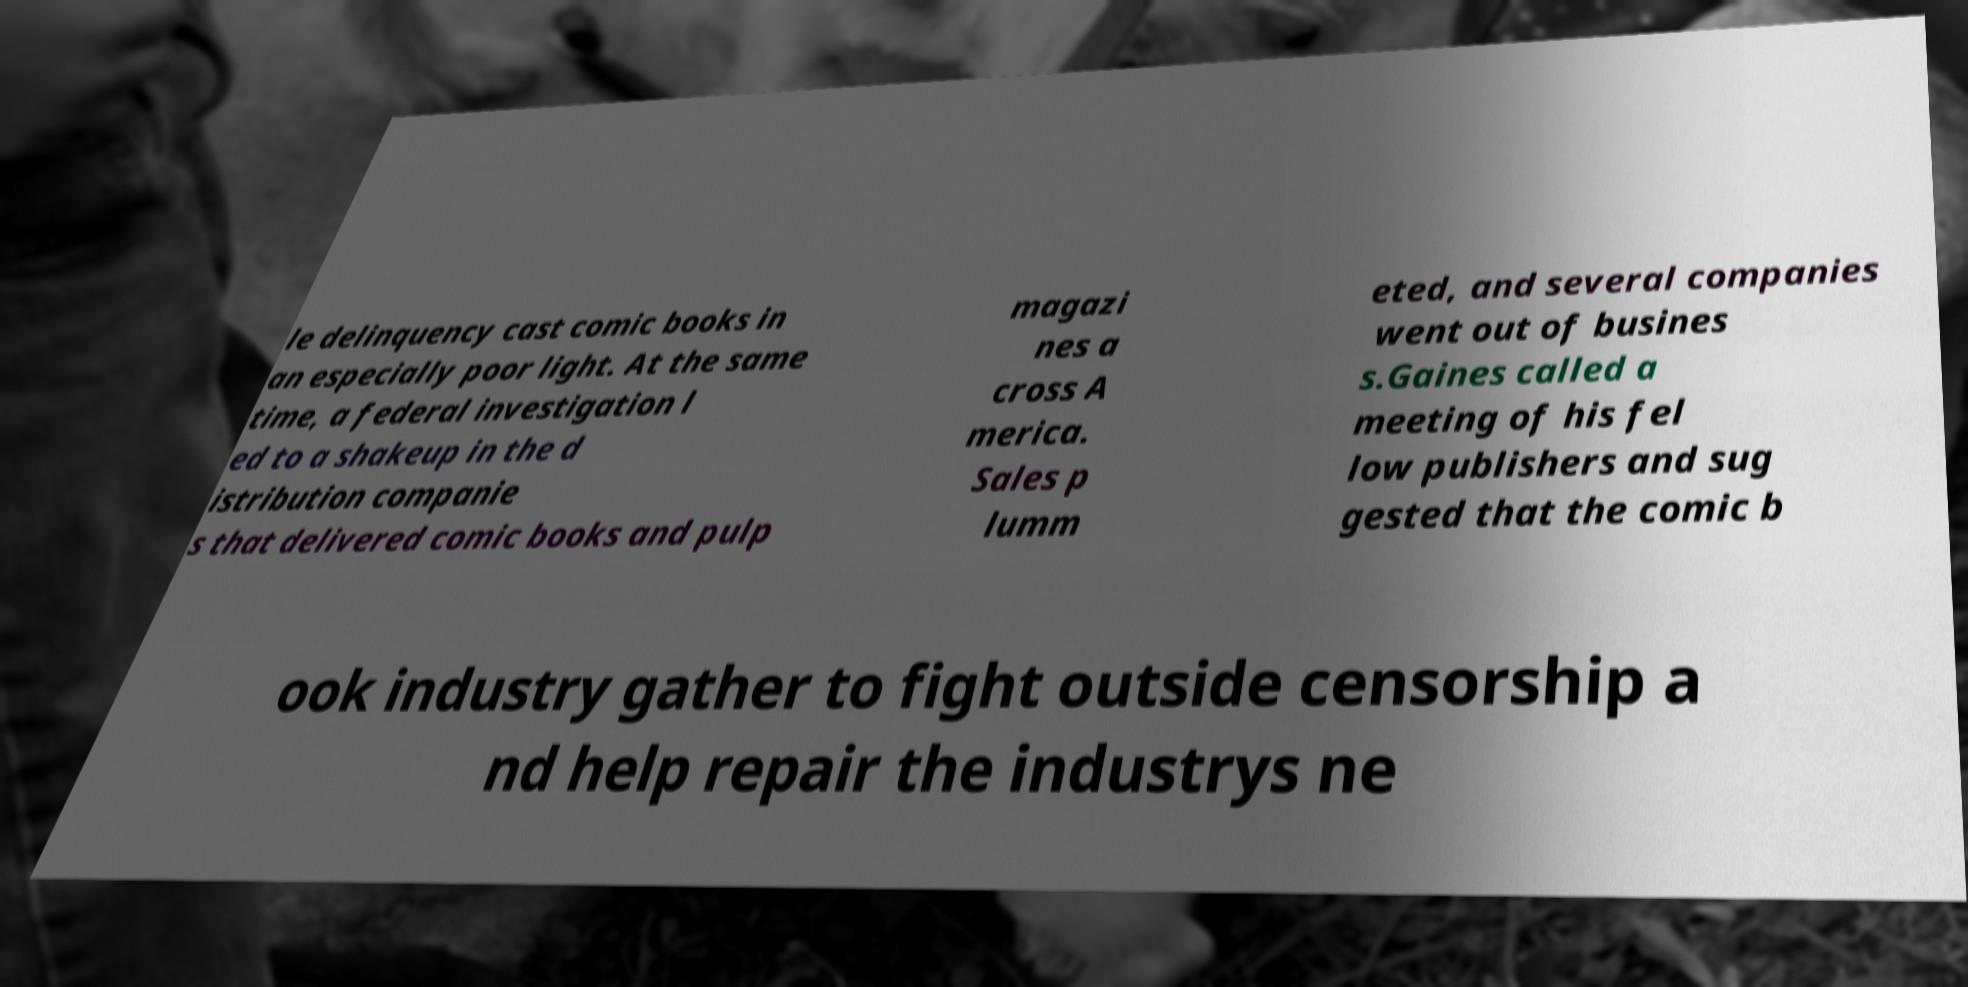There's text embedded in this image that I need extracted. Can you transcribe it verbatim? le delinquency cast comic books in an especially poor light. At the same time, a federal investigation l ed to a shakeup in the d istribution companie s that delivered comic books and pulp magazi nes a cross A merica. Sales p lumm eted, and several companies went out of busines s.Gaines called a meeting of his fel low publishers and sug gested that the comic b ook industry gather to fight outside censorship a nd help repair the industrys ne 